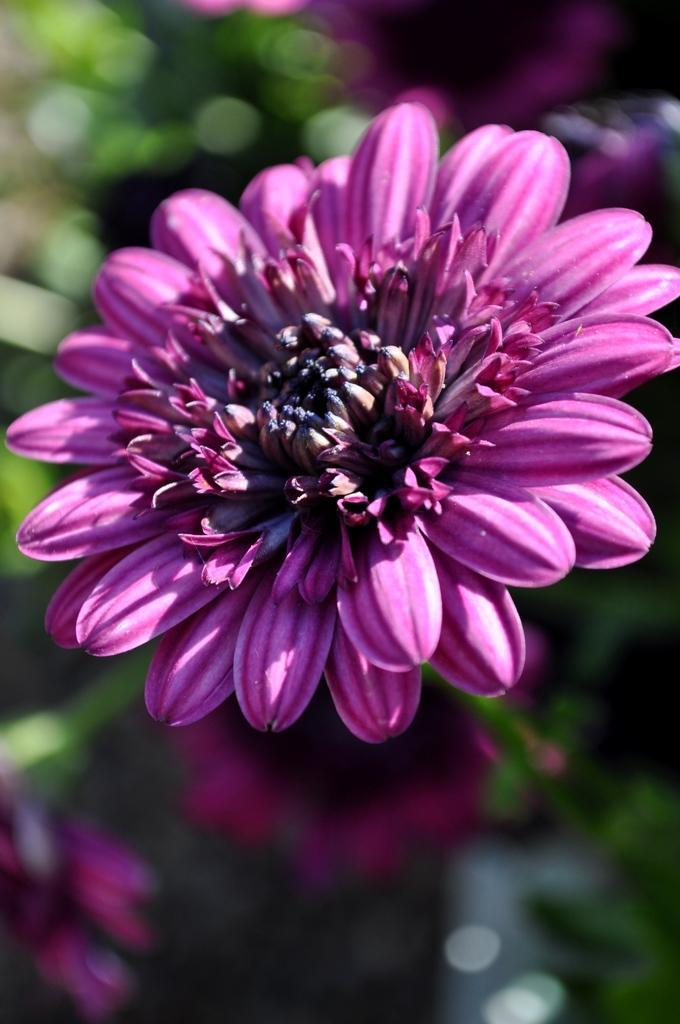In one or two sentences, can you explain what this image depicts? In this image, we can see a flower. Background there is a blur view. Here we can see few flowers and green color. 